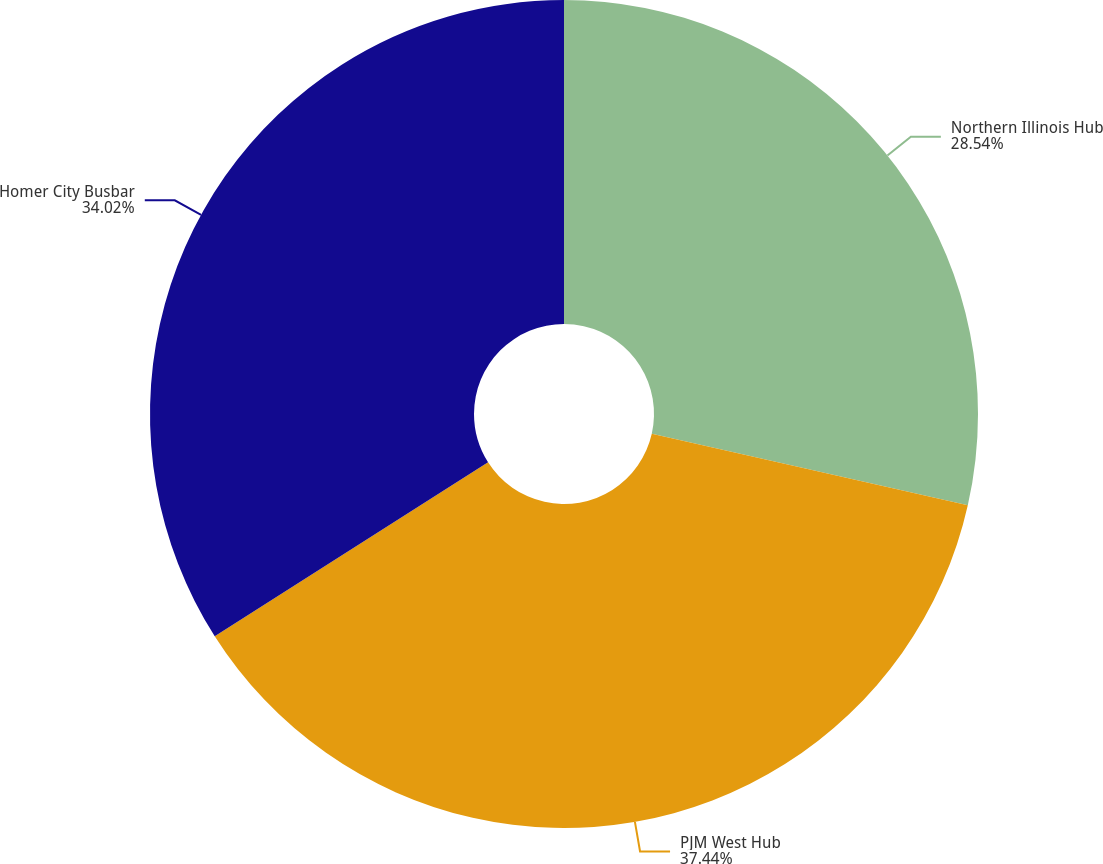Convert chart. <chart><loc_0><loc_0><loc_500><loc_500><pie_chart><fcel>Northern Illinois Hub<fcel>PJM West Hub<fcel>Homer City Busbar<nl><fcel>28.54%<fcel>37.44%<fcel>34.02%<nl></chart> 